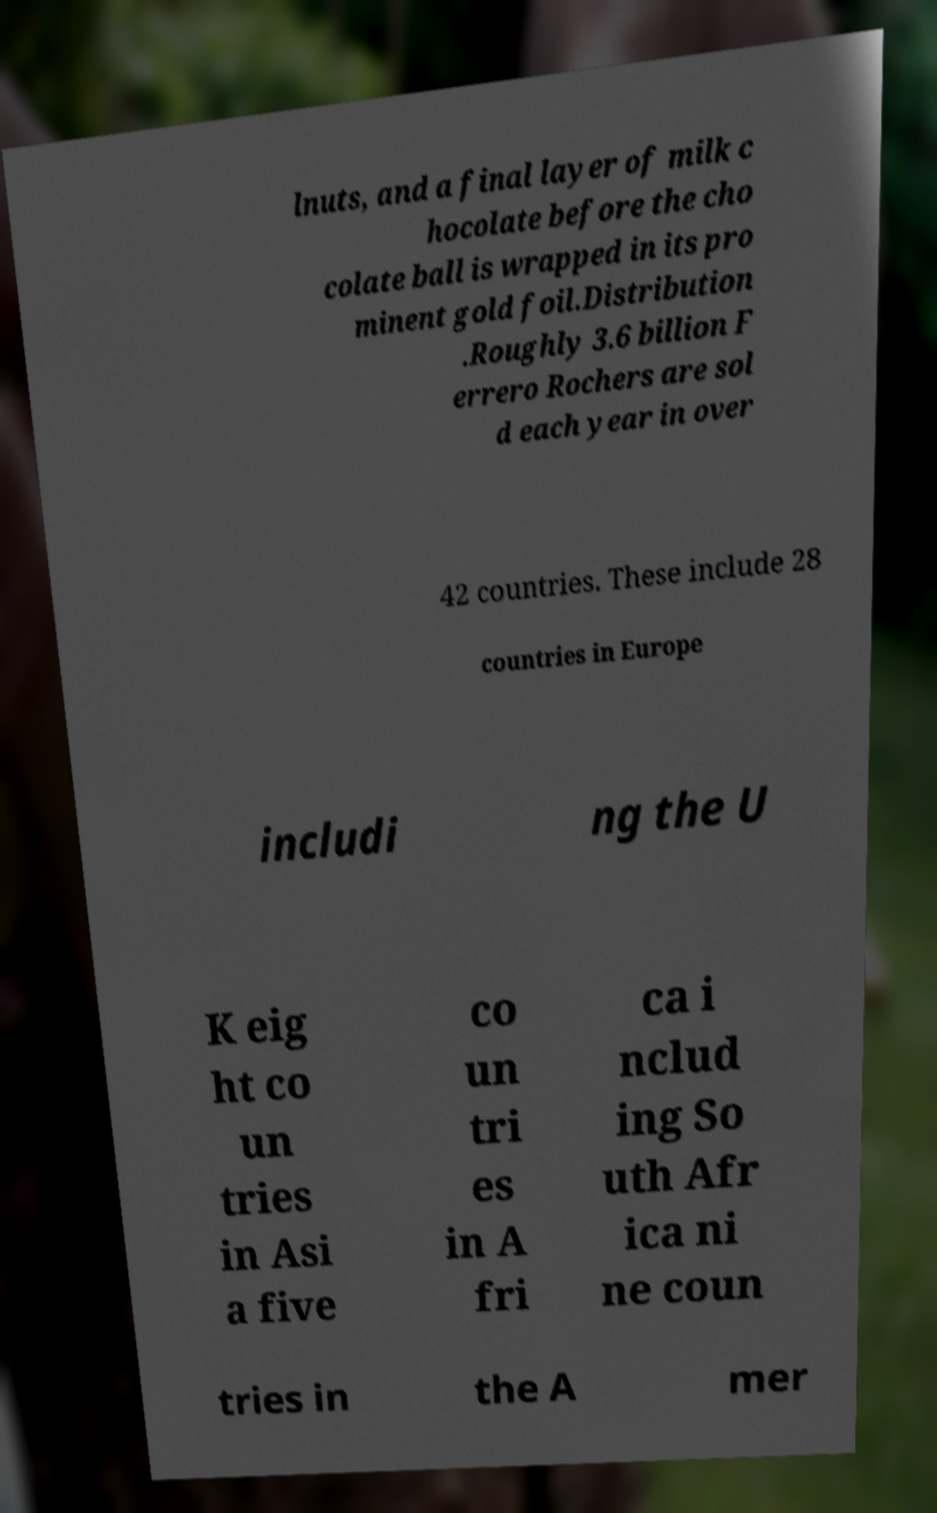Please read and relay the text visible in this image. What does it say? lnuts, and a final layer of milk c hocolate before the cho colate ball is wrapped in its pro minent gold foil.Distribution .Roughly 3.6 billion F errero Rochers are sol d each year in over 42 countries. These include 28 countries in Europe includi ng the U K eig ht co un tries in Asi a five co un tri es in A fri ca i nclud ing So uth Afr ica ni ne coun tries in the A mer 